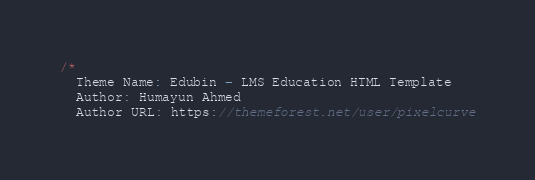<code> <loc_0><loc_0><loc_500><loc_500><_JavaScript_>/*
  Theme Name: Edubin - LMS Education HTML Template
  Author: Humayun Ahmed
  Author URL: https://themeforest.net/user/pixelcurve</code> 